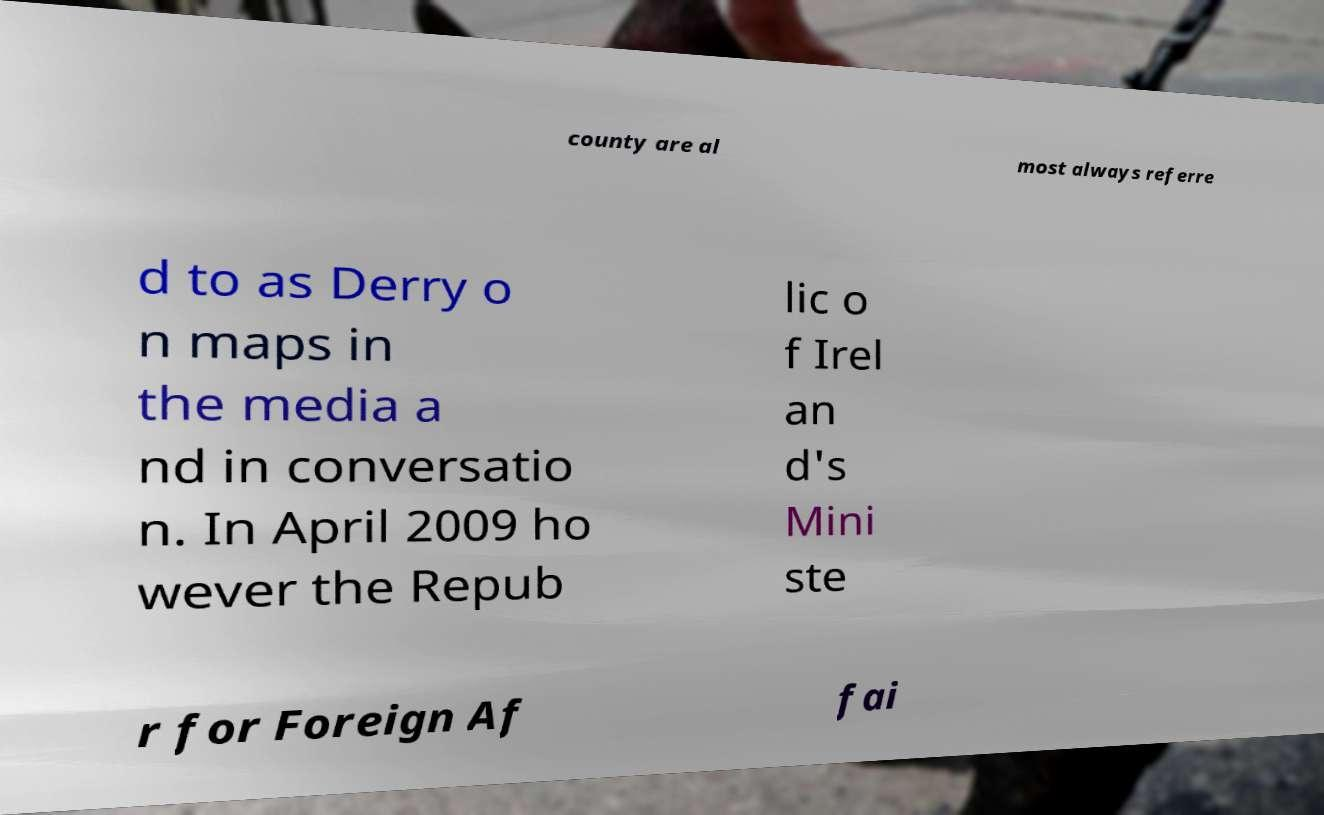What messages or text are displayed in this image? I need them in a readable, typed format. county are al most always referre d to as Derry o n maps in the media a nd in conversatio n. In April 2009 ho wever the Repub lic o f Irel an d's Mini ste r for Foreign Af fai 